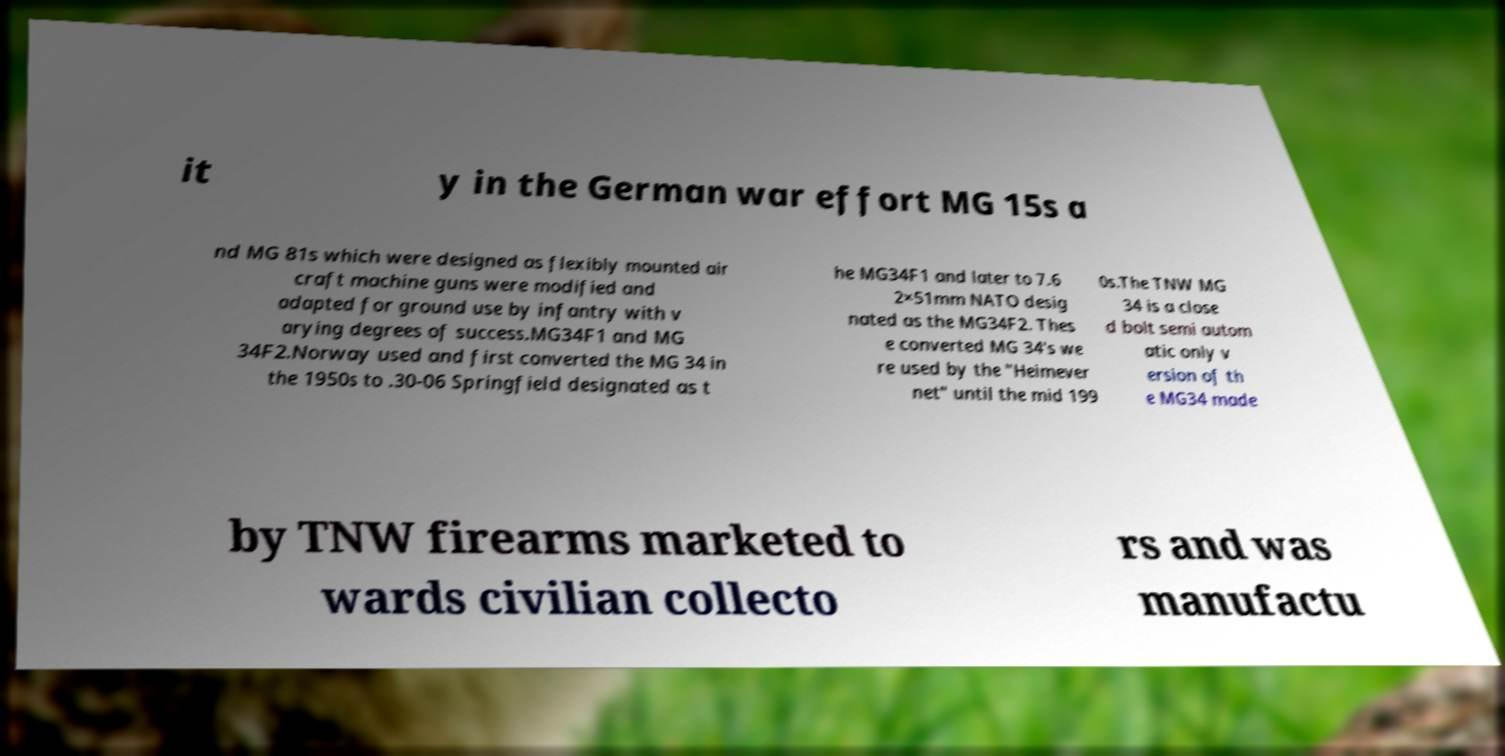Can you read and provide the text displayed in the image?This photo seems to have some interesting text. Can you extract and type it out for me? it y in the German war effort MG 15s a nd MG 81s which were designed as flexibly mounted air craft machine guns were modified and adapted for ground use by infantry with v arying degrees of success.MG34F1 and MG 34F2.Norway used and first converted the MG 34 in the 1950s to .30-06 Springfield designated as t he MG34F1 and later to 7.6 2×51mm NATO desig nated as the MG34F2. Thes e converted MG 34's we re used by the "Heimever net" until the mid 199 0s.The TNW MG 34 is a close d bolt semi autom atic only v ersion of th e MG34 made by TNW firearms marketed to wards civilian collecto rs and was manufactu 